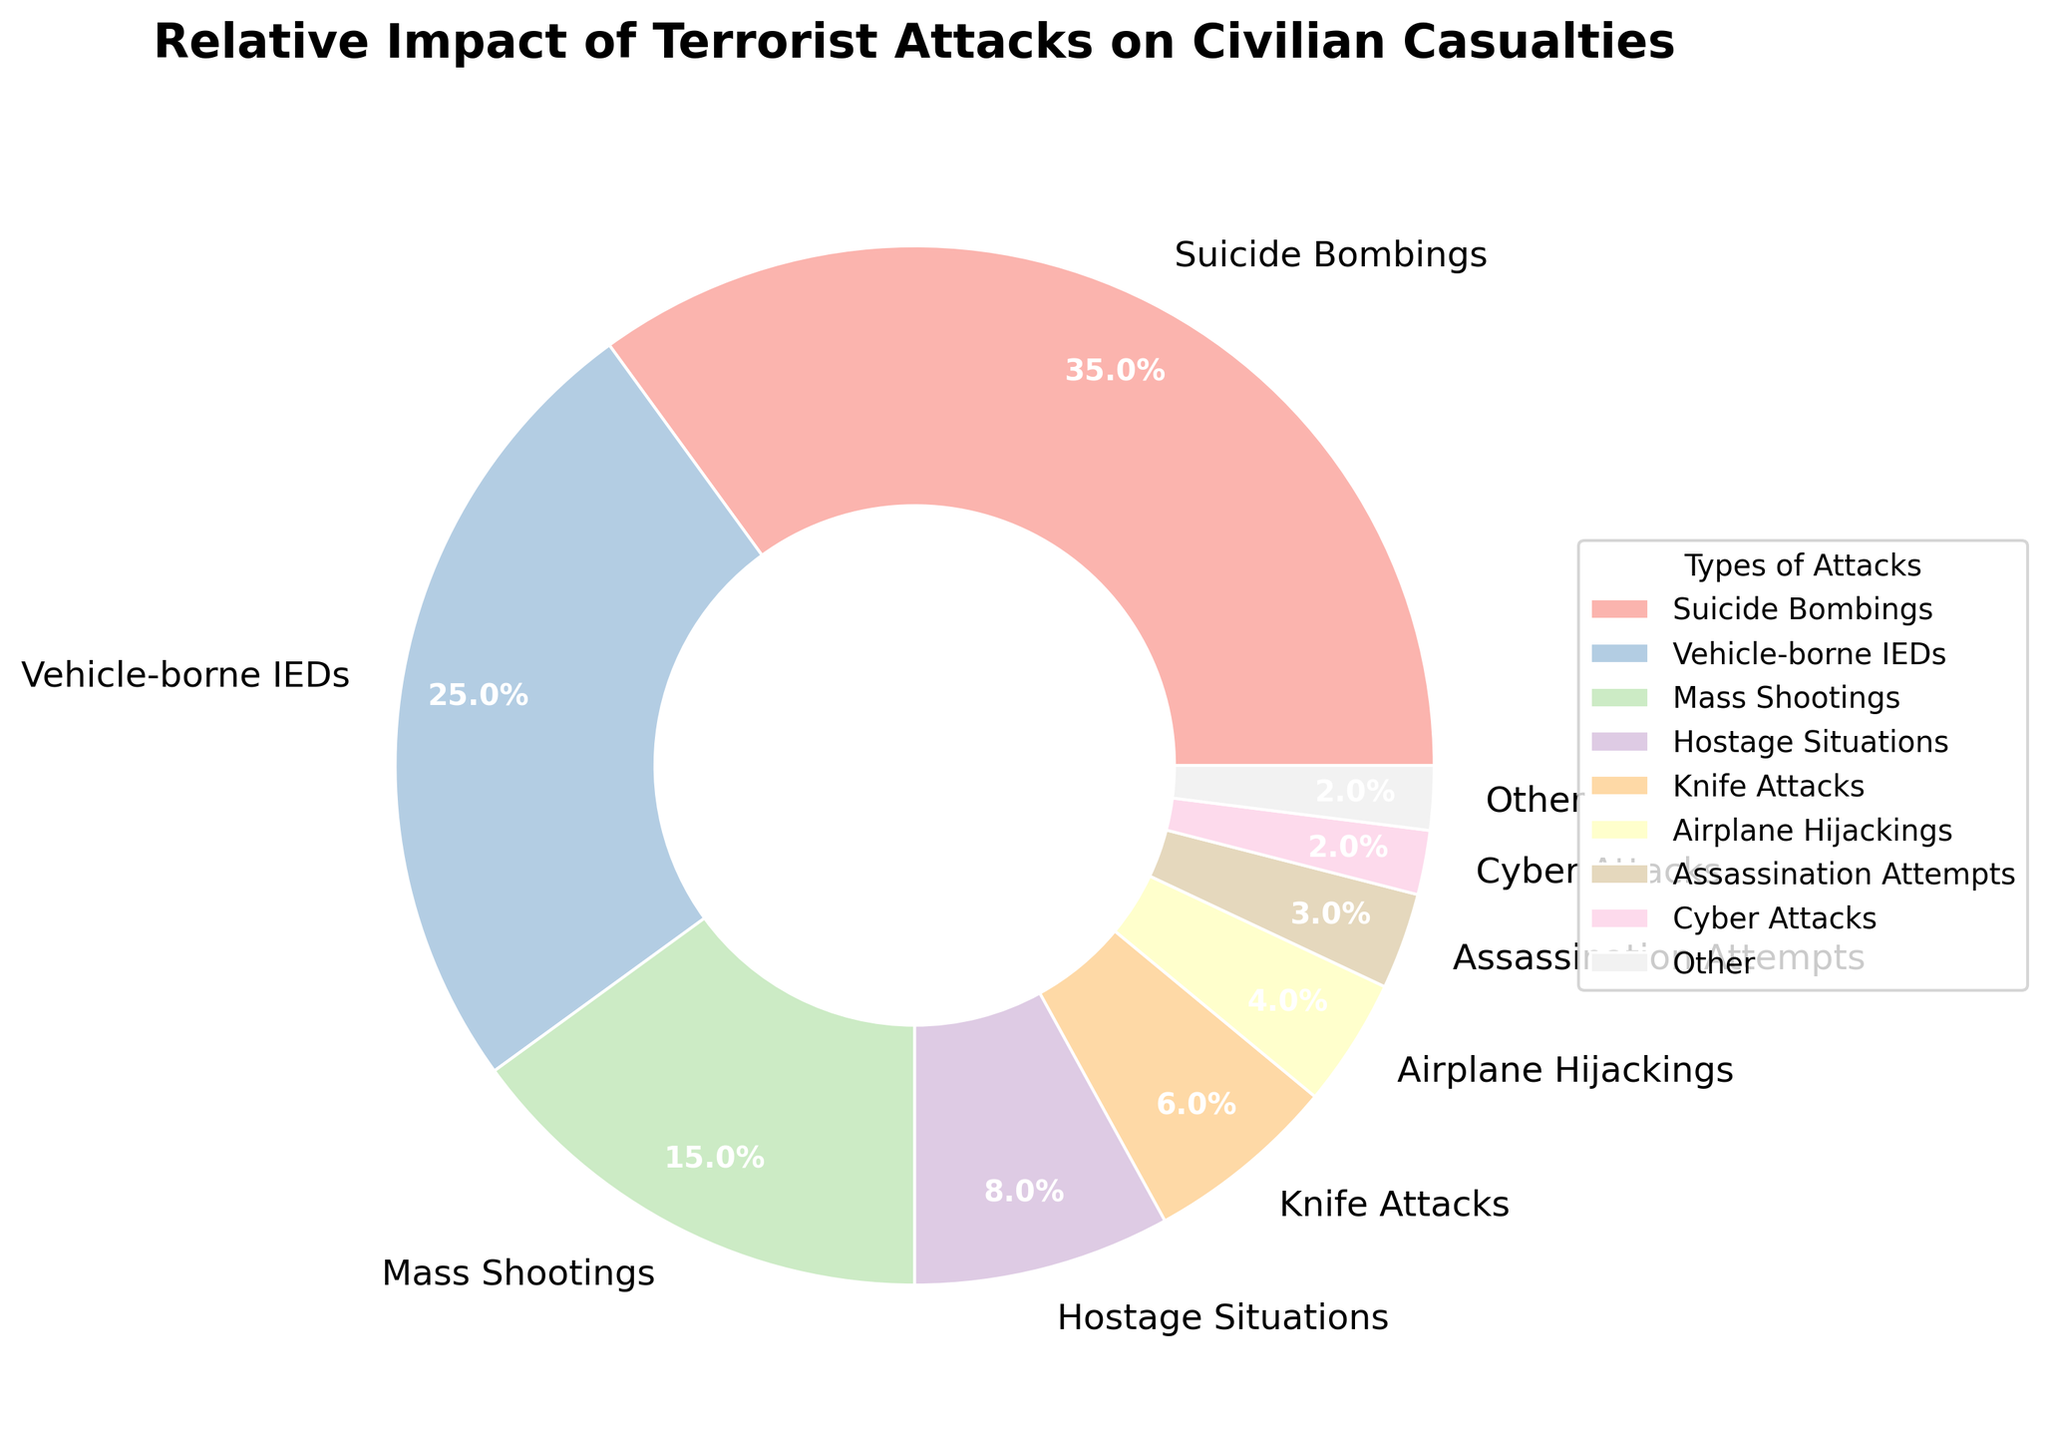Which type of attack has the highest percentage of civilian casualties? The pie chart shows that Suicide Bombings have the largest section.
Answer: Suicide Bombings What is the combined percentage of civilian casualties from Hostage Situations and Knife Attacks? Add the percentage for Hostage Situations (8%) and Knife Attacks (6%) from the pie chart. 8% + 6% = 14%
Answer: 14% Of the attacks listed, which one has the smallest percentage of civilian casualties included in the "Other" category? By looking at the pie chart, "Other" includes types like Radiological Attacks (0.3%) and Nuclear Threats (0.2%). The smallest among these is Nuclear Threats with 0.2%.
Answer: Nuclear Threats How does the percentage of Vehicle-borne IEDs compare to that of Mass Shootings? According to the pie chart, Vehicle-borne IEDs are at 25% while Mass Shootings are at 15%. 25% is greater than 15%.
Answer: Vehicle-borne IEDs have a higher percentage What is the visual representation color for Assassination Attempts in the pie chart? Observe the color segment for Assassination Attempts in the chart. It is represented in one of the colors from the pastel color palette used.
Answer: (Color from the chart) Are there more civilian casualties from Cyber Attacks or Chemical Weapons? By comparing the percentages on the pie chart: Cyber Attacks have 2% and Chemical Weapons have 1%. 2% is higher than 1%.
Answer: Cyber Attacks What percentage is represented by the "Other" category? Sum the percentages of all types of attacks with percentages lower than 2%: Assassination Attempts (3%), Cyber Attacks (2%), Chemical Weapons (1%), Biological Weapons (0.5%), Radiological Attacks (0.3%), and Nuclear Threats (0.2%), which is already combined in the chart as "Other".
Answer: Look at the "Other" segment on the pie chart which includes these attacks combined What is the difference in percentage between Suicide Bombings and Vehicle-borne IEDs? The percentage for Suicide Bombings is 35% and for Vehicle-borne IEDs is 25%. Subtract the smaller percentage from the larger one: 35% - 25% = 10%.
Answer: 10% Which types of attacks form the top three in terms of percentage of civilian casualties? From the pie chart, identify the three largest segments. They correspond to Suicide Bombings (35%), Vehicle-borne IEDs (25%), and Mass Shootings (15%).
Answer: Suicide Bombings, Vehicle-borne IEDs, Mass Shootings If you combine the percentages of Mass Shootings, Hostage Situations, and Knife Attacks, what fraction of the total civilian casualties do they account for? Add the percentages for these three types: 15% (Mass Shootings) + 8% (Hostage Situations) + 6% (Knife Attacks) = 29%. Since this is out of a total of 100%, the fraction is 29/100 = 0.29.
Answer: 0.29 